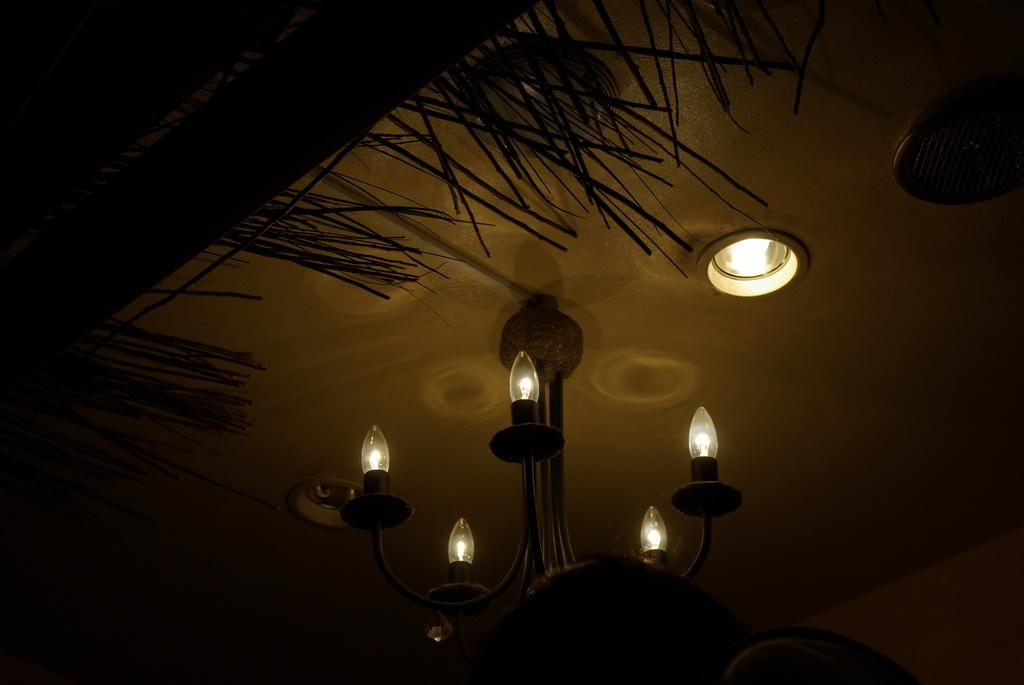What is the overall lighting condition in the image? The image is dark. What type of lighting fixture is present in the image? There is a chandelier in the image. Are there any other light sources visible in the image? Yes, there are lights in the image. What can be seen in the image besides the lighting fixtures? There are objects in the image. What type of string is being used to hold the rail in the image? There is no rail or string present in the image; it only features a chandelier and other objects. What is the zephyr's role in the image? There is no zephyr present in the image; it is a term used to describe a gentle breeze, which is not depicted. 